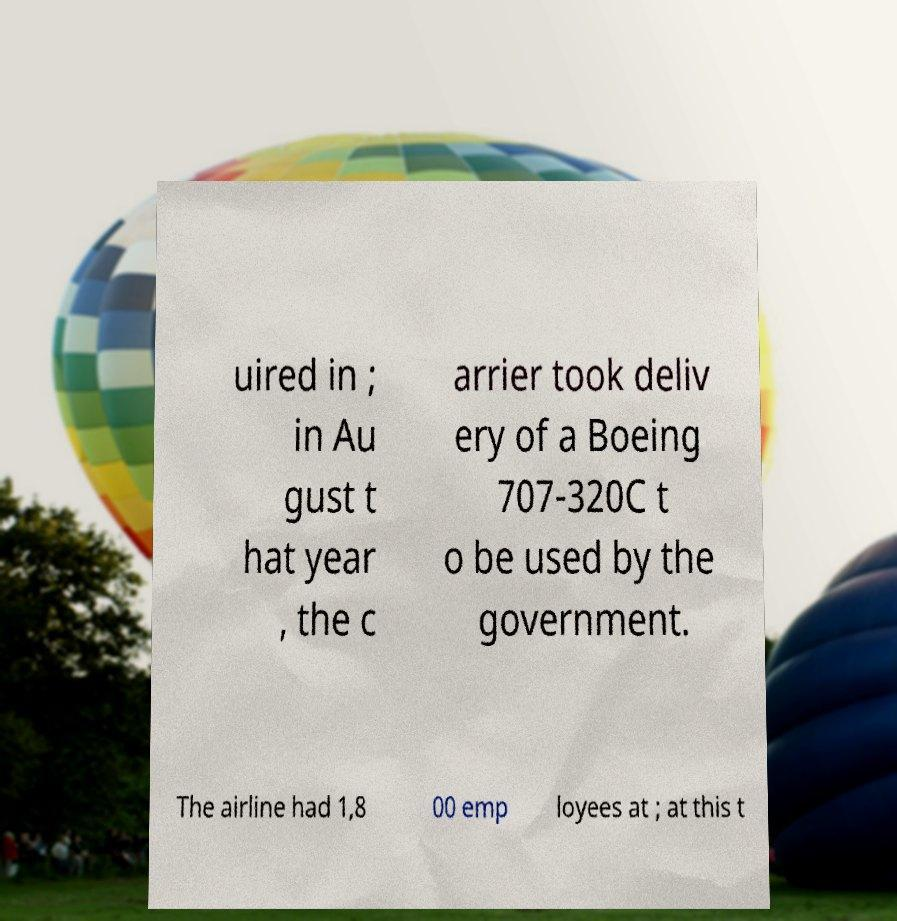Can you accurately transcribe the text from the provided image for me? uired in ; in Au gust t hat year , the c arrier took deliv ery of a Boeing 707-320C t o be used by the government. The airline had 1,8 00 emp loyees at ; at this t 